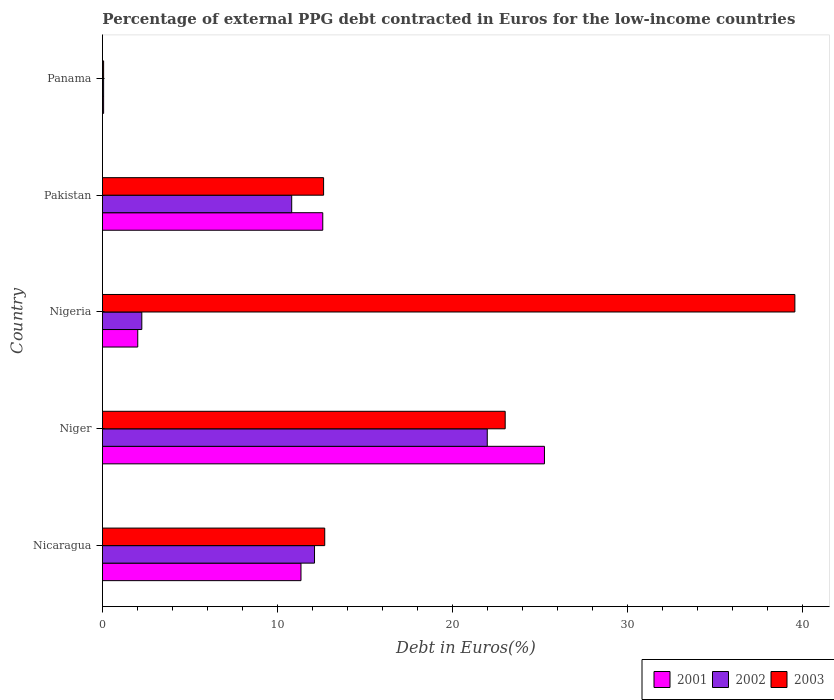How many different coloured bars are there?
Provide a short and direct response. 3. Are the number of bars on each tick of the Y-axis equal?
Offer a terse response. Yes. How many bars are there on the 3rd tick from the bottom?
Keep it short and to the point. 3. What is the label of the 5th group of bars from the top?
Your response must be concise. Nicaragua. What is the percentage of external PPG debt contracted in Euros in 2001 in Niger?
Keep it short and to the point. 25.25. Across all countries, what is the maximum percentage of external PPG debt contracted in Euros in 2002?
Your response must be concise. 21.99. Across all countries, what is the minimum percentage of external PPG debt contracted in Euros in 2003?
Keep it short and to the point. 0.07. In which country was the percentage of external PPG debt contracted in Euros in 2003 maximum?
Your answer should be very brief. Nigeria. In which country was the percentage of external PPG debt contracted in Euros in 2001 minimum?
Ensure brevity in your answer.  Panama. What is the total percentage of external PPG debt contracted in Euros in 2002 in the graph?
Provide a succinct answer. 47.23. What is the difference between the percentage of external PPG debt contracted in Euros in 2001 in Nicaragua and that in Nigeria?
Your answer should be compact. 9.33. What is the difference between the percentage of external PPG debt contracted in Euros in 2001 in Nicaragua and the percentage of external PPG debt contracted in Euros in 2002 in Niger?
Your response must be concise. -10.64. What is the average percentage of external PPG debt contracted in Euros in 2003 per country?
Your answer should be very brief. 17.59. What is the difference between the percentage of external PPG debt contracted in Euros in 2001 and percentage of external PPG debt contracted in Euros in 2002 in Pakistan?
Provide a succinct answer. 1.77. What is the ratio of the percentage of external PPG debt contracted in Euros in 2002 in Nigeria to that in Panama?
Your response must be concise. 34.21. What is the difference between the highest and the second highest percentage of external PPG debt contracted in Euros in 2002?
Your answer should be compact. 9.87. What is the difference between the highest and the lowest percentage of external PPG debt contracted in Euros in 2002?
Your answer should be compact. 21.92. In how many countries, is the percentage of external PPG debt contracted in Euros in 2003 greater than the average percentage of external PPG debt contracted in Euros in 2003 taken over all countries?
Give a very brief answer. 2. Is the sum of the percentage of external PPG debt contracted in Euros in 2003 in Niger and Pakistan greater than the maximum percentage of external PPG debt contracted in Euros in 2001 across all countries?
Make the answer very short. Yes. How many bars are there?
Ensure brevity in your answer.  15. Are all the bars in the graph horizontal?
Ensure brevity in your answer.  Yes. What is the difference between two consecutive major ticks on the X-axis?
Offer a very short reply. 10. Does the graph contain grids?
Your answer should be very brief. No. How are the legend labels stacked?
Provide a short and direct response. Horizontal. What is the title of the graph?
Your answer should be compact. Percentage of external PPG debt contracted in Euros for the low-income countries. Does "2004" appear as one of the legend labels in the graph?
Your answer should be very brief. No. What is the label or title of the X-axis?
Offer a terse response. Debt in Euros(%). What is the label or title of the Y-axis?
Offer a terse response. Country. What is the Debt in Euros(%) in 2001 in Nicaragua?
Provide a succinct answer. 11.34. What is the Debt in Euros(%) of 2002 in Nicaragua?
Ensure brevity in your answer.  12.12. What is the Debt in Euros(%) of 2003 in Nicaragua?
Your answer should be compact. 12.7. What is the Debt in Euros(%) in 2001 in Niger?
Offer a very short reply. 25.25. What is the Debt in Euros(%) of 2002 in Niger?
Give a very brief answer. 21.99. What is the Debt in Euros(%) in 2003 in Niger?
Provide a succinct answer. 23.01. What is the Debt in Euros(%) of 2001 in Nigeria?
Offer a terse response. 2.02. What is the Debt in Euros(%) in 2002 in Nigeria?
Offer a terse response. 2.25. What is the Debt in Euros(%) of 2003 in Nigeria?
Ensure brevity in your answer.  39.56. What is the Debt in Euros(%) of 2001 in Pakistan?
Give a very brief answer. 12.59. What is the Debt in Euros(%) in 2002 in Pakistan?
Your response must be concise. 10.81. What is the Debt in Euros(%) of 2003 in Pakistan?
Keep it short and to the point. 12.63. What is the Debt in Euros(%) in 2001 in Panama?
Offer a terse response. 0.06. What is the Debt in Euros(%) in 2002 in Panama?
Provide a short and direct response. 0.07. What is the Debt in Euros(%) in 2003 in Panama?
Your response must be concise. 0.07. Across all countries, what is the maximum Debt in Euros(%) of 2001?
Provide a succinct answer. 25.25. Across all countries, what is the maximum Debt in Euros(%) in 2002?
Offer a terse response. 21.99. Across all countries, what is the maximum Debt in Euros(%) in 2003?
Your response must be concise. 39.56. Across all countries, what is the minimum Debt in Euros(%) in 2001?
Make the answer very short. 0.06. Across all countries, what is the minimum Debt in Euros(%) in 2002?
Provide a short and direct response. 0.07. Across all countries, what is the minimum Debt in Euros(%) of 2003?
Offer a terse response. 0.07. What is the total Debt in Euros(%) of 2001 in the graph?
Give a very brief answer. 51.26. What is the total Debt in Euros(%) in 2002 in the graph?
Your answer should be compact. 47.23. What is the total Debt in Euros(%) in 2003 in the graph?
Make the answer very short. 87.97. What is the difference between the Debt in Euros(%) of 2001 in Nicaragua and that in Niger?
Offer a terse response. -13.91. What is the difference between the Debt in Euros(%) of 2002 in Nicaragua and that in Niger?
Make the answer very short. -9.87. What is the difference between the Debt in Euros(%) in 2003 in Nicaragua and that in Niger?
Provide a short and direct response. -10.31. What is the difference between the Debt in Euros(%) of 2001 in Nicaragua and that in Nigeria?
Keep it short and to the point. 9.33. What is the difference between the Debt in Euros(%) of 2002 in Nicaragua and that in Nigeria?
Your response must be concise. 9.87. What is the difference between the Debt in Euros(%) of 2003 in Nicaragua and that in Nigeria?
Your answer should be very brief. -26.86. What is the difference between the Debt in Euros(%) of 2001 in Nicaragua and that in Pakistan?
Your answer should be very brief. -1.24. What is the difference between the Debt in Euros(%) of 2002 in Nicaragua and that in Pakistan?
Provide a short and direct response. 1.3. What is the difference between the Debt in Euros(%) of 2003 in Nicaragua and that in Pakistan?
Your answer should be compact. 0.07. What is the difference between the Debt in Euros(%) in 2001 in Nicaragua and that in Panama?
Offer a very short reply. 11.28. What is the difference between the Debt in Euros(%) in 2002 in Nicaragua and that in Panama?
Your answer should be very brief. 12.05. What is the difference between the Debt in Euros(%) in 2003 in Nicaragua and that in Panama?
Make the answer very short. 12.63. What is the difference between the Debt in Euros(%) of 2001 in Niger and that in Nigeria?
Provide a succinct answer. 23.24. What is the difference between the Debt in Euros(%) in 2002 in Niger and that in Nigeria?
Your answer should be compact. 19.74. What is the difference between the Debt in Euros(%) in 2003 in Niger and that in Nigeria?
Your answer should be compact. -16.55. What is the difference between the Debt in Euros(%) in 2001 in Niger and that in Pakistan?
Ensure brevity in your answer.  12.67. What is the difference between the Debt in Euros(%) of 2002 in Niger and that in Pakistan?
Offer a very short reply. 11.17. What is the difference between the Debt in Euros(%) of 2003 in Niger and that in Pakistan?
Ensure brevity in your answer.  10.38. What is the difference between the Debt in Euros(%) of 2001 in Niger and that in Panama?
Ensure brevity in your answer.  25.19. What is the difference between the Debt in Euros(%) in 2002 in Niger and that in Panama?
Keep it short and to the point. 21.92. What is the difference between the Debt in Euros(%) of 2003 in Niger and that in Panama?
Your answer should be compact. 22.94. What is the difference between the Debt in Euros(%) of 2001 in Nigeria and that in Pakistan?
Your answer should be very brief. -10.57. What is the difference between the Debt in Euros(%) of 2002 in Nigeria and that in Pakistan?
Offer a terse response. -8.56. What is the difference between the Debt in Euros(%) in 2003 in Nigeria and that in Pakistan?
Your response must be concise. 26.93. What is the difference between the Debt in Euros(%) of 2001 in Nigeria and that in Panama?
Provide a succinct answer. 1.95. What is the difference between the Debt in Euros(%) in 2002 in Nigeria and that in Panama?
Ensure brevity in your answer.  2.18. What is the difference between the Debt in Euros(%) in 2003 in Nigeria and that in Panama?
Make the answer very short. 39.49. What is the difference between the Debt in Euros(%) in 2001 in Pakistan and that in Panama?
Your answer should be very brief. 12.52. What is the difference between the Debt in Euros(%) in 2002 in Pakistan and that in Panama?
Provide a short and direct response. 10.75. What is the difference between the Debt in Euros(%) in 2003 in Pakistan and that in Panama?
Make the answer very short. 12.57. What is the difference between the Debt in Euros(%) in 2001 in Nicaragua and the Debt in Euros(%) in 2002 in Niger?
Give a very brief answer. -10.64. What is the difference between the Debt in Euros(%) in 2001 in Nicaragua and the Debt in Euros(%) in 2003 in Niger?
Make the answer very short. -11.67. What is the difference between the Debt in Euros(%) in 2002 in Nicaragua and the Debt in Euros(%) in 2003 in Niger?
Ensure brevity in your answer.  -10.89. What is the difference between the Debt in Euros(%) in 2001 in Nicaragua and the Debt in Euros(%) in 2002 in Nigeria?
Keep it short and to the point. 9.09. What is the difference between the Debt in Euros(%) of 2001 in Nicaragua and the Debt in Euros(%) of 2003 in Nigeria?
Provide a succinct answer. -28.22. What is the difference between the Debt in Euros(%) of 2002 in Nicaragua and the Debt in Euros(%) of 2003 in Nigeria?
Your answer should be compact. -27.44. What is the difference between the Debt in Euros(%) of 2001 in Nicaragua and the Debt in Euros(%) of 2002 in Pakistan?
Offer a very short reply. 0.53. What is the difference between the Debt in Euros(%) of 2001 in Nicaragua and the Debt in Euros(%) of 2003 in Pakistan?
Offer a terse response. -1.29. What is the difference between the Debt in Euros(%) in 2002 in Nicaragua and the Debt in Euros(%) in 2003 in Pakistan?
Provide a short and direct response. -0.52. What is the difference between the Debt in Euros(%) of 2001 in Nicaragua and the Debt in Euros(%) of 2002 in Panama?
Your response must be concise. 11.28. What is the difference between the Debt in Euros(%) of 2001 in Nicaragua and the Debt in Euros(%) of 2003 in Panama?
Keep it short and to the point. 11.28. What is the difference between the Debt in Euros(%) of 2002 in Nicaragua and the Debt in Euros(%) of 2003 in Panama?
Offer a very short reply. 12.05. What is the difference between the Debt in Euros(%) of 2001 in Niger and the Debt in Euros(%) of 2002 in Nigeria?
Keep it short and to the point. 23.01. What is the difference between the Debt in Euros(%) of 2001 in Niger and the Debt in Euros(%) of 2003 in Nigeria?
Provide a short and direct response. -14.31. What is the difference between the Debt in Euros(%) in 2002 in Niger and the Debt in Euros(%) in 2003 in Nigeria?
Your answer should be very brief. -17.57. What is the difference between the Debt in Euros(%) in 2001 in Niger and the Debt in Euros(%) in 2002 in Pakistan?
Give a very brief answer. 14.44. What is the difference between the Debt in Euros(%) in 2001 in Niger and the Debt in Euros(%) in 2003 in Pakistan?
Provide a short and direct response. 12.62. What is the difference between the Debt in Euros(%) of 2002 in Niger and the Debt in Euros(%) of 2003 in Pakistan?
Your response must be concise. 9.35. What is the difference between the Debt in Euros(%) in 2001 in Niger and the Debt in Euros(%) in 2002 in Panama?
Give a very brief answer. 25.19. What is the difference between the Debt in Euros(%) of 2001 in Niger and the Debt in Euros(%) of 2003 in Panama?
Your response must be concise. 25.19. What is the difference between the Debt in Euros(%) in 2002 in Niger and the Debt in Euros(%) in 2003 in Panama?
Give a very brief answer. 21.92. What is the difference between the Debt in Euros(%) of 2001 in Nigeria and the Debt in Euros(%) of 2002 in Pakistan?
Your answer should be compact. -8.8. What is the difference between the Debt in Euros(%) of 2001 in Nigeria and the Debt in Euros(%) of 2003 in Pakistan?
Offer a terse response. -10.62. What is the difference between the Debt in Euros(%) of 2002 in Nigeria and the Debt in Euros(%) of 2003 in Pakistan?
Offer a very short reply. -10.39. What is the difference between the Debt in Euros(%) in 2001 in Nigeria and the Debt in Euros(%) in 2002 in Panama?
Keep it short and to the point. 1.95. What is the difference between the Debt in Euros(%) of 2001 in Nigeria and the Debt in Euros(%) of 2003 in Panama?
Your answer should be compact. 1.95. What is the difference between the Debt in Euros(%) of 2002 in Nigeria and the Debt in Euros(%) of 2003 in Panama?
Offer a very short reply. 2.18. What is the difference between the Debt in Euros(%) in 2001 in Pakistan and the Debt in Euros(%) in 2002 in Panama?
Provide a succinct answer. 12.52. What is the difference between the Debt in Euros(%) of 2001 in Pakistan and the Debt in Euros(%) of 2003 in Panama?
Provide a succinct answer. 12.52. What is the difference between the Debt in Euros(%) of 2002 in Pakistan and the Debt in Euros(%) of 2003 in Panama?
Give a very brief answer. 10.75. What is the average Debt in Euros(%) in 2001 per country?
Keep it short and to the point. 10.25. What is the average Debt in Euros(%) in 2002 per country?
Offer a terse response. 9.45. What is the average Debt in Euros(%) in 2003 per country?
Provide a short and direct response. 17.59. What is the difference between the Debt in Euros(%) of 2001 and Debt in Euros(%) of 2002 in Nicaragua?
Give a very brief answer. -0.77. What is the difference between the Debt in Euros(%) in 2001 and Debt in Euros(%) in 2003 in Nicaragua?
Give a very brief answer. -1.36. What is the difference between the Debt in Euros(%) in 2002 and Debt in Euros(%) in 2003 in Nicaragua?
Ensure brevity in your answer.  -0.58. What is the difference between the Debt in Euros(%) of 2001 and Debt in Euros(%) of 2002 in Niger?
Your response must be concise. 3.27. What is the difference between the Debt in Euros(%) in 2001 and Debt in Euros(%) in 2003 in Niger?
Make the answer very short. 2.24. What is the difference between the Debt in Euros(%) of 2002 and Debt in Euros(%) of 2003 in Niger?
Provide a succinct answer. -1.02. What is the difference between the Debt in Euros(%) in 2001 and Debt in Euros(%) in 2002 in Nigeria?
Offer a very short reply. -0.23. What is the difference between the Debt in Euros(%) of 2001 and Debt in Euros(%) of 2003 in Nigeria?
Your answer should be very brief. -37.54. What is the difference between the Debt in Euros(%) of 2002 and Debt in Euros(%) of 2003 in Nigeria?
Make the answer very short. -37.31. What is the difference between the Debt in Euros(%) of 2001 and Debt in Euros(%) of 2002 in Pakistan?
Your answer should be very brief. 1.77. What is the difference between the Debt in Euros(%) of 2001 and Debt in Euros(%) of 2003 in Pakistan?
Offer a terse response. -0.05. What is the difference between the Debt in Euros(%) in 2002 and Debt in Euros(%) in 2003 in Pakistan?
Ensure brevity in your answer.  -1.82. What is the difference between the Debt in Euros(%) in 2001 and Debt in Euros(%) in 2002 in Panama?
Your answer should be compact. -0. What is the difference between the Debt in Euros(%) of 2001 and Debt in Euros(%) of 2003 in Panama?
Keep it short and to the point. -0. What is the ratio of the Debt in Euros(%) in 2001 in Nicaragua to that in Niger?
Ensure brevity in your answer.  0.45. What is the ratio of the Debt in Euros(%) in 2002 in Nicaragua to that in Niger?
Provide a short and direct response. 0.55. What is the ratio of the Debt in Euros(%) of 2003 in Nicaragua to that in Niger?
Make the answer very short. 0.55. What is the ratio of the Debt in Euros(%) of 2001 in Nicaragua to that in Nigeria?
Offer a very short reply. 5.63. What is the ratio of the Debt in Euros(%) of 2002 in Nicaragua to that in Nigeria?
Keep it short and to the point. 5.39. What is the ratio of the Debt in Euros(%) of 2003 in Nicaragua to that in Nigeria?
Make the answer very short. 0.32. What is the ratio of the Debt in Euros(%) of 2001 in Nicaragua to that in Pakistan?
Offer a terse response. 0.9. What is the ratio of the Debt in Euros(%) in 2002 in Nicaragua to that in Pakistan?
Your response must be concise. 1.12. What is the ratio of the Debt in Euros(%) in 2001 in Nicaragua to that in Panama?
Your answer should be compact. 174.76. What is the ratio of the Debt in Euros(%) of 2002 in Nicaragua to that in Panama?
Make the answer very short. 184.41. What is the ratio of the Debt in Euros(%) of 2003 in Nicaragua to that in Panama?
Your response must be concise. 193.29. What is the ratio of the Debt in Euros(%) in 2001 in Niger to that in Nigeria?
Your response must be concise. 12.53. What is the ratio of the Debt in Euros(%) of 2002 in Niger to that in Nigeria?
Your response must be concise. 9.78. What is the ratio of the Debt in Euros(%) in 2003 in Niger to that in Nigeria?
Provide a succinct answer. 0.58. What is the ratio of the Debt in Euros(%) of 2001 in Niger to that in Pakistan?
Your answer should be compact. 2.01. What is the ratio of the Debt in Euros(%) of 2002 in Niger to that in Pakistan?
Your answer should be compact. 2.03. What is the ratio of the Debt in Euros(%) of 2003 in Niger to that in Pakistan?
Make the answer very short. 1.82. What is the ratio of the Debt in Euros(%) of 2001 in Niger to that in Panama?
Your response must be concise. 389.1. What is the ratio of the Debt in Euros(%) in 2002 in Niger to that in Panama?
Provide a succinct answer. 334.63. What is the ratio of the Debt in Euros(%) in 2003 in Niger to that in Panama?
Offer a very short reply. 350.22. What is the ratio of the Debt in Euros(%) of 2001 in Nigeria to that in Pakistan?
Give a very brief answer. 0.16. What is the ratio of the Debt in Euros(%) in 2002 in Nigeria to that in Pakistan?
Provide a succinct answer. 0.21. What is the ratio of the Debt in Euros(%) of 2003 in Nigeria to that in Pakistan?
Your answer should be very brief. 3.13. What is the ratio of the Debt in Euros(%) of 2001 in Nigeria to that in Panama?
Your answer should be compact. 31.06. What is the ratio of the Debt in Euros(%) in 2002 in Nigeria to that in Panama?
Make the answer very short. 34.21. What is the ratio of the Debt in Euros(%) of 2003 in Nigeria to that in Panama?
Your answer should be compact. 602.13. What is the ratio of the Debt in Euros(%) of 2001 in Pakistan to that in Panama?
Keep it short and to the point. 193.94. What is the ratio of the Debt in Euros(%) of 2002 in Pakistan to that in Panama?
Offer a very short reply. 164.57. What is the ratio of the Debt in Euros(%) of 2003 in Pakistan to that in Panama?
Offer a very short reply. 192.3. What is the difference between the highest and the second highest Debt in Euros(%) in 2001?
Offer a very short reply. 12.67. What is the difference between the highest and the second highest Debt in Euros(%) in 2002?
Give a very brief answer. 9.87. What is the difference between the highest and the second highest Debt in Euros(%) of 2003?
Your response must be concise. 16.55. What is the difference between the highest and the lowest Debt in Euros(%) of 2001?
Provide a succinct answer. 25.19. What is the difference between the highest and the lowest Debt in Euros(%) in 2002?
Offer a terse response. 21.92. What is the difference between the highest and the lowest Debt in Euros(%) of 2003?
Make the answer very short. 39.49. 